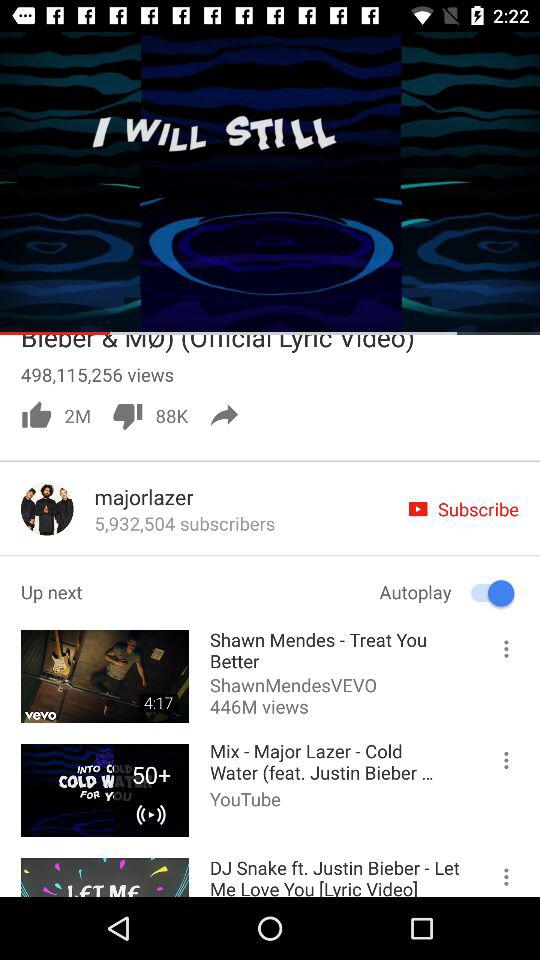How many thumbs up does the video have?
Answer the question using a single word or phrase. 3M 